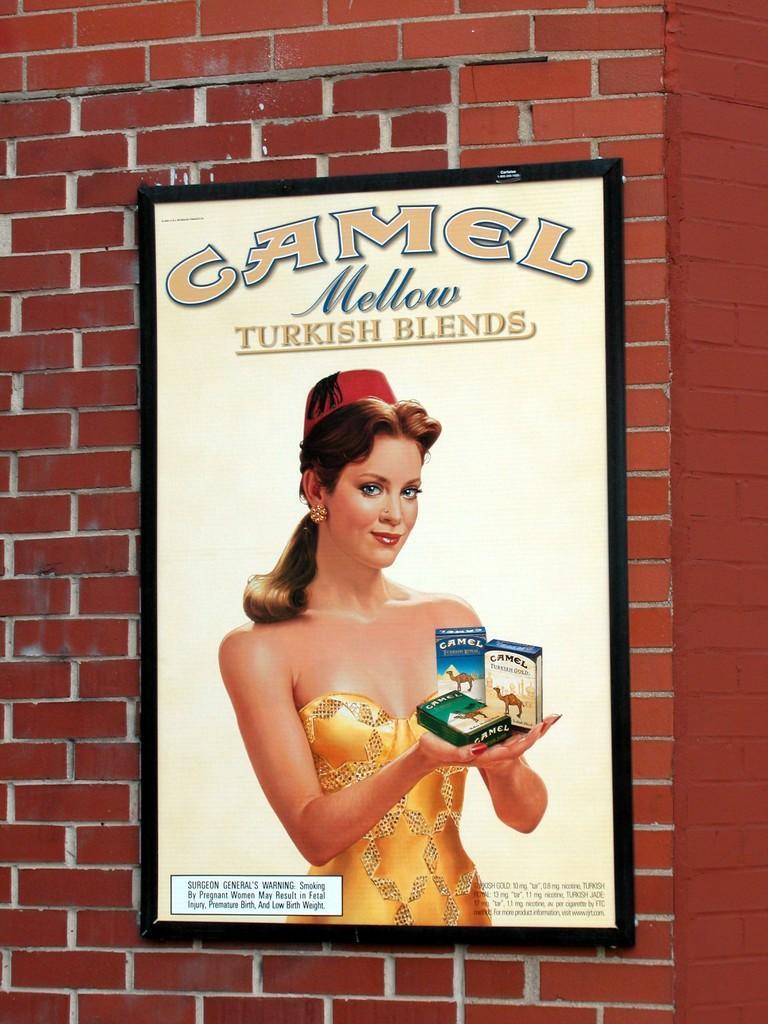How would you summarize this image in a sentence or two? In this image we can see the photo frame on the wall, in which we can see a woman holding some objects in her hand and some text on it. 